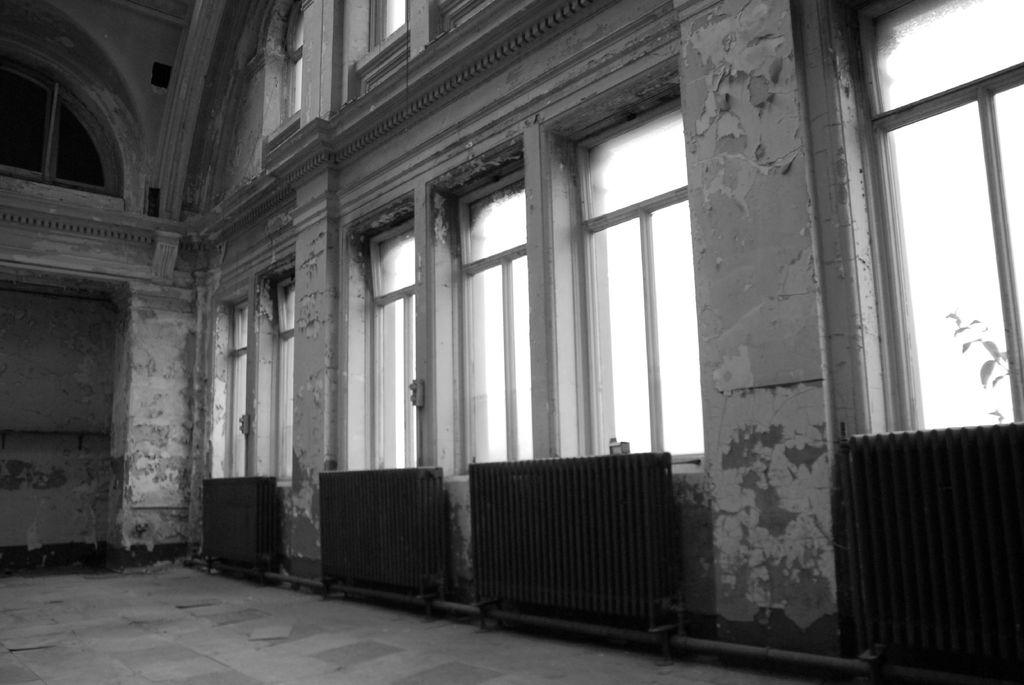Where was the image taken? The image was taken inside a building. What can be seen in the foreground of the image? There are windows, a wall, and iron objects in the foreground of the image. What is located on the left side of the image? There is a well on the left side of the image. What effect does the coil have on the feet in the image? There are no coils or feet present in the image. 